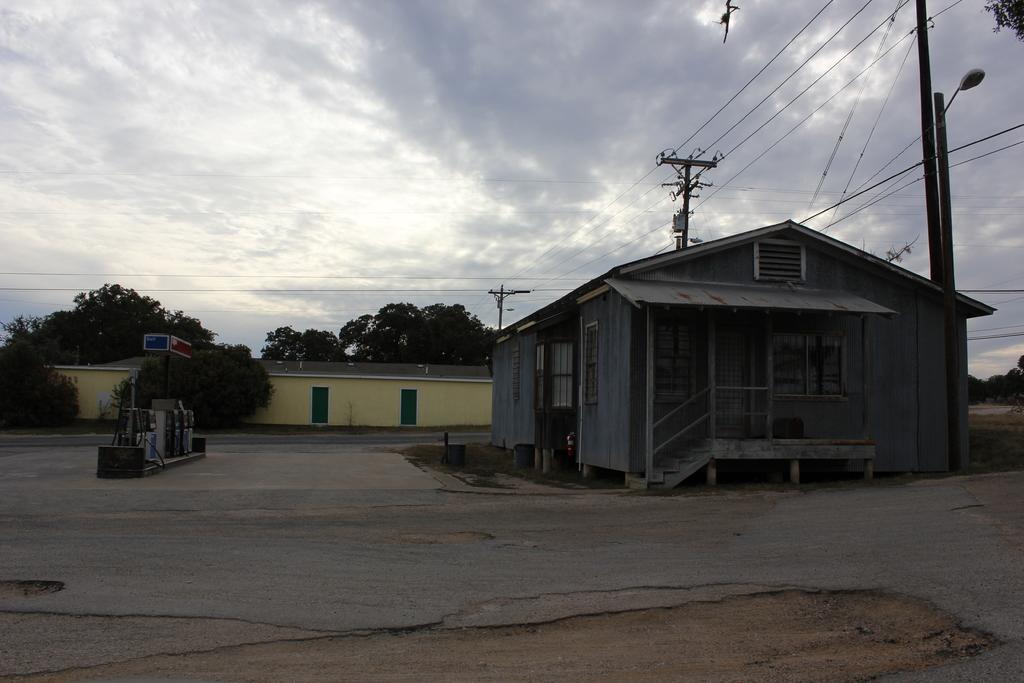Can you describe this image briefly? In this image we can see the houses, there are some trees, poles, wires, lights, boards, doors and some other objects, in the background, we can see the sky with clouds. 